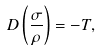<formula> <loc_0><loc_0><loc_500><loc_500>D \left ( \frac { \sigma } { \rho } \right ) = - T ,</formula> 